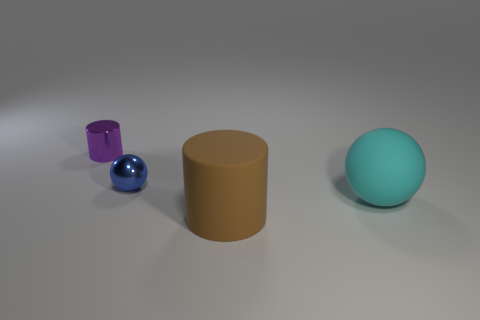Add 3 cyan matte things. How many objects exist? 7 Add 3 shiny spheres. How many shiny spheres are left? 4 Add 3 tiny green matte spheres. How many tiny green matte spheres exist? 3 Subtract 0 green cubes. How many objects are left? 4 Subtract 2 cylinders. How many cylinders are left? 0 Subtract all yellow spheres. Subtract all yellow cylinders. How many spheres are left? 2 Subtract all purple cubes. How many green cylinders are left? 0 Subtract all purple cylinders. Subtract all big brown things. How many objects are left? 2 